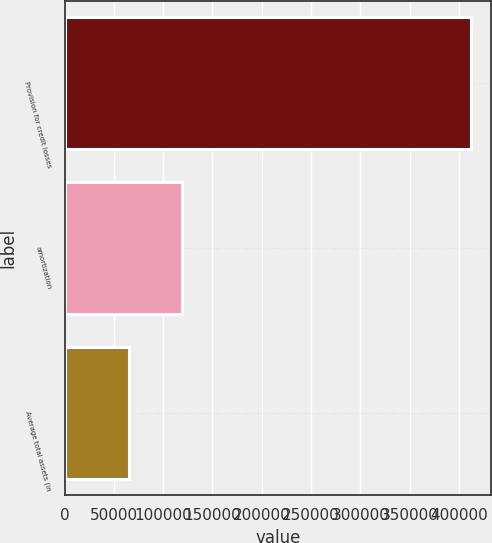Convert chart. <chart><loc_0><loc_0><loc_500><loc_500><bar_chart><fcel>Provision for credit losses<fcel>amortization<fcel>Average total assets (in<nl><fcel>412000<fcel>119144<fcel>65132<nl></chart> 